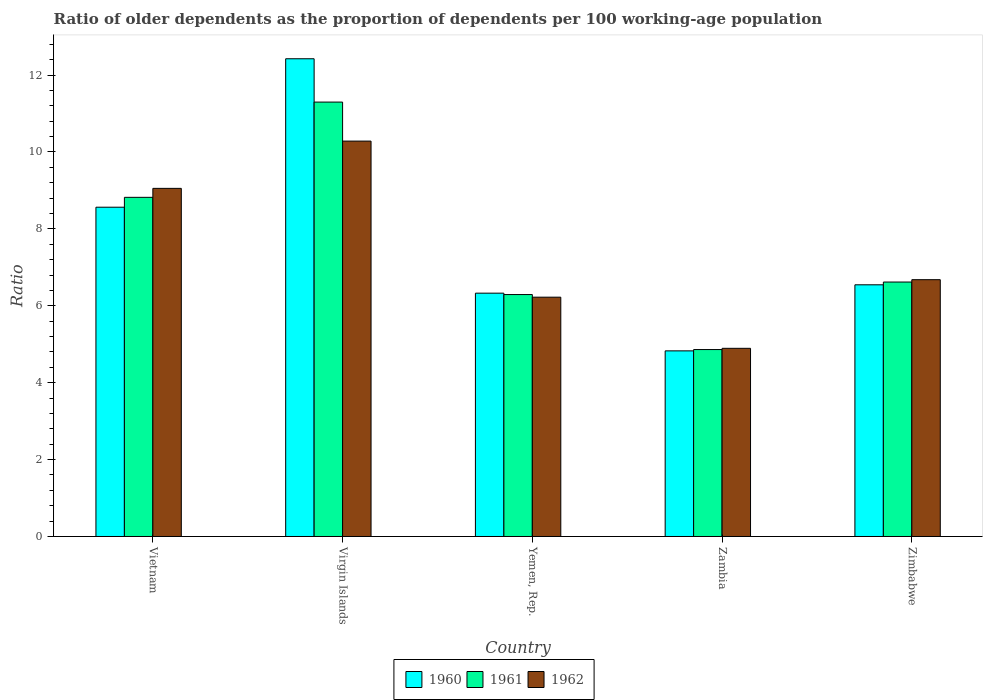How many different coloured bars are there?
Your answer should be very brief. 3. How many groups of bars are there?
Keep it short and to the point. 5. Are the number of bars per tick equal to the number of legend labels?
Provide a short and direct response. Yes. Are the number of bars on each tick of the X-axis equal?
Your answer should be compact. Yes. How many bars are there on the 3rd tick from the left?
Give a very brief answer. 3. How many bars are there on the 5th tick from the right?
Keep it short and to the point. 3. What is the label of the 1st group of bars from the left?
Ensure brevity in your answer.  Vietnam. In how many cases, is the number of bars for a given country not equal to the number of legend labels?
Provide a short and direct response. 0. What is the age dependency ratio(old) in 1961 in Zambia?
Provide a short and direct response. 4.86. Across all countries, what is the maximum age dependency ratio(old) in 1960?
Keep it short and to the point. 12.42. Across all countries, what is the minimum age dependency ratio(old) in 1962?
Your answer should be compact. 4.89. In which country was the age dependency ratio(old) in 1962 maximum?
Offer a very short reply. Virgin Islands. In which country was the age dependency ratio(old) in 1960 minimum?
Your response must be concise. Zambia. What is the total age dependency ratio(old) in 1961 in the graph?
Offer a very short reply. 37.89. What is the difference between the age dependency ratio(old) in 1961 in Virgin Islands and that in Zimbabwe?
Your answer should be compact. 4.68. What is the difference between the age dependency ratio(old) in 1960 in Vietnam and the age dependency ratio(old) in 1962 in Zimbabwe?
Provide a short and direct response. 1.88. What is the average age dependency ratio(old) in 1961 per country?
Provide a succinct answer. 7.58. What is the difference between the age dependency ratio(old) of/in 1961 and age dependency ratio(old) of/in 1962 in Zambia?
Offer a very short reply. -0.03. What is the ratio of the age dependency ratio(old) in 1961 in Zambia to that in Zimbabwe?
Offer a terse response. 0.73. Is the age dependency ratio(old) in 1961 in Vietnam less than that in Yemen, Rep.?
Keep it short and to the point. No. Is the difference between the age dependency ratio(old) in 1961 in Vietnam and Zambia greater than the difference between the age dependency ratio(old) in 1962 in Vietnam and Zambia?
Make the answer very short. No. What is the difference between the highest and the second highest age dependency ratio(old) in 1962?
Offer a very short reply. -1.23. What is the difference between the highest and the lowest age dependency ratio(old) in 1961?
Ensure brevity in your answer.  6.44. Is the sum of the age dependency ratio(old) in 1960 in Yemen, Rep. and Zambia greater than the maximum age dependency ratio(old) in 1961 across all countries?
Ensure brevity in your answer.  No. What does the 2nd bar from the right in Yemen, Rep. represents?
Offer a terse response. 1961. Is it the case that in every country, the sum of the age dependency ratio(old) in 1961 and age dependency ratio(old) in 1962 is greater than the age dependency ratio(old) in 1960?
Your answer should be very brief. Yes. What is the difference between two consecutive major ticks on the Y-axis?
Your answer should be very brief. 2. Are the values on the major ticks of Y-axis written in scientific E-notation?
Provide a short and direct response. No. Does the graph contain grids?
Your response must be concise. No. Where does the legend appear in the graph?
Make the answer very short. Bottom center. How many legend labels are there?
Give a very brief answer. 3. What is the title of the graph?
Your response must be concise. Ratio of older dependents as the proportion of dependents per 100 working-age population. What is the label or title of the X-axis?
Make the answer very short. Country. What is the label or title of the Y-axis?
Keep it short and to the point. Ratio. What is the Ratio in 1960 in Vietnam?
Your answer should be compact. 8.56. What is the Ratio of 1961 in Vietnam?
Your response must be concise. 8.82. What is the Ratio of 1962 in Vietnam?
Ensure brevity in your answer.  9.05. What is the Ratio in 1960 in Virgin Islands?
Your answer should be compact. 12.42. What is the Ratio in 1961 in Virgin Islands?
Provide a short and direct response. 11.3. What is the Ratio in 1962 in Virgin Islands?
Keep it short and to the point. 10.28. What is the Ratio in 1960 in Yemen, Rep.?
Your answer should be very brief. 6.33. What is the Ratio of 1961 in Yemen, Rep.?
Ensure brevity in your answer.  6.29. What is the Ratio of 1962 in Yemen, Rep.?
Ensure brevity in your answer.  6.22. What is the Ratio of 1960 in Zambia?
Your answer should be compact. 4.83. What is the Ratio of 1961 in Zambia?
Keep it short and to the point. 4.86. What is the Ratio of 1962 in Zambia?
Provide a succinct answer. 4.89. What is the Ratio in 1960 in Zimbabwe?
Provide a succinct answer. 6.55. What is the Ratio in 1961 in Zimbabwe?
Your answer should be very brief. 6.62. What is the Ratio of 1962 in Zimbabwe?
Your answer should be compact. 6.68. Across all countries, what is the maximum Ratio in 1960?
Provide a short and direct response. 12.42. Across all countries, what is the maximum Ratio in 1961?
Provide a short and direct response. 11.3. Across all countries, what is the maximum Ratio in 1962?
Give a very brief answer. 10.28. Across all countries, what is the minimum Ratio in 1960?
Give a very brief answer. 4.83. Across all countries, what is the minimum Ratio of 1961?
Offer a terse response. 4.86. Across all countries, what is the minimum Ratio in 1962?
Your response must be concise. 4.89. What is the total Ratio in 1960 in the graph?
Make the answer very short. 38.69. What is the total Ratio in 1961 in the graph?
Your answer should be compact. 37.89. What is the total Ratio of 1962 in the graph?
Make the answer very short. 37.13. What is the difference between the Ratio of 1960 in Vietnam and that in Virgin Islands?
Your answer should be very brief. -3.86. What is the difference between the Ratio in 1961 in Vietnam and that in Virgin Islands?
Make the answer very short. -2.48. What is the difference between the Ratio of 1962 in Vietnam and that in Virgin Islands?
Offer a terse response. -1.23. What is the difference between the Ratio in 1960 in Vietnam and that in Yemen, Rep.?
Make the answer very short. 2.24. What is the difference between the Ratio in 1961 in Vietnam and that in Yemen, Rep.?
Give a very brief answer. 2.53. What is the difference between the Ratio in 1962 in Vietnam and that in Yemen, Rep.?
Keep it short and to the point. 2.83. What is the difference between the Ratio of 1960 in Vietnam and that in Zambia?
Your response must be concise. 3.74. What is the difference between the Ratio in 1961 in Vietnam and that in Zambia?
Offer a terse response. 3.96. What is the difference between the Ratio in 1962 in Vietnam and that in Zambia?
Your answer should be very brief. 4.16. What is the difference between the Ratio in 1960 in Vietnam and that in Zimbabwe?
Ensure brevity in your answer.  2.02. What is the difference between the Ratio of 1961 in Vietnam and that in Zimbabwe?
Your response must be concise. 2.2. What is the difference between the Ratio in 1962 in Vietnam and that in Zimbabwe?
Give a very brief answer. 2.37. What is the difference between the Ratio of 1960 in Virgin Islands and that in Yemen, Rep.?
Make the answer very short. 6.1. What is the difference between the Ratio of 1961 in Virgin Islands and that in Yemen, Rep.?
Offer a very short reply. 5.01. What is the difference between the Ratio in 1962 in Virgin Islands and that in Yemen, Rep.?
Your answer should be very brief. 4.06. What is the difference between the Ratio of 1960 in Virgin Islands and that in Zambia?
Your response must be concise. 7.6. What is the difference between the Ratio of 1961 in Virgin Islands and that in Zambia?
Your answer should be very brief. 6.44. What is the difference between the Ratio in 1962 in Virgin Islands and that in Zambia?
Provide a short and direct response. 5.39. What is the difference between the Ratio in 1960 in Virgin Islands and that in Zimbabwe?
Your answer should be compact. 5.88. What is the difference between the Ratio of 1961 in Virgin Islands and that in Zimbabwe?
Offer a very short reply. 4.68. What is the difference between the Ratio of 1962 in Virgin Islands and that in Zimbabwe?
Your answer should be very brief. 3.6. What is the difference between the Ratio of 1960 in Yemen, Rep. and that in Zambia?
Give a very brief answer. 1.5. What is the difference between the Ratio in 1961 in Yemen, Rep. and that in Zambia?
Your answer should be very brief. 1.43. What is the difference between the Ratio in 1962 in Yemen, Rep. and that in Zambia?
Offer a terse response. 1.33. What is the difference between the Ratio of 1960 in Yemen, Rep. and that in Zimbabwe?
Give a very brief answer. -0.22. What is the difference between the Ratio of 1961 in Yemen, Rep. and that in Zimbabwe?
Offer a very short reply. -0.33. What is the difference between the Ratio of 1962 in Yemen, Rep. and that in Zimbabwe?
Your answer should be very brief. -0.46. What is the difference between the Ratio of 1960 in Zambia and that in Zimbabwe?
Keep it short and to the point. -1.72. What is the difference between the Ratio in 1961 in Zambia and that in Zimbabwe?
Offer a terse response. -1.76. What is the difference between the Ratio in 1962 in Zambia and that in Zimbabwe?
Offer a terse response. -1.79. What is the difference between the Ratio of 1960 in Vietnam and the Ratio of 1961 in Virgin Islands?
Your answer should be very brief. -2.73. What is the difference between the Ratio of 1960 in Vietnam and the Ratio of 1962 in Virgin Islands?
Your answer should be very brief. -1.72. What is the difference between the Ratio of 1961 in Vietnam and the Ratio of 1962 in Virgin Islands?
Keep it short and to the point. -1.46. What is the difference between the Ratio of 1960 in Vietnam and the Ratio of 1961 in Yemen, Rep.?
Make the answer very short. 2.27. What is the difference between the Ratio of 1960 in Vietnam and the Ratio of 1962 in Yemen, Rep.?
Make the answer very short. 2.34. What is the difference between the Ratio of 1961 in Vietnam and the Ratio of 1962 in Yemen, Rep.?
Keep it short and to the point. 2.6. What is the difference between the Ratio in 1960 in Vietnam and the Ratio in 1961 in Zambia?
Your response must be concise. 3.7. What is the difference between the Ratio of 1960 in Vietnam and the Ratio of 1962 in Zambia?
Ensure brevity in your answer.  3.67. What is the difference between the Ratio in 1961 in Vietnam and the Ratio in 1962 in Zambia?
Your answer should be compact. 3.93. What is the difference between the Ratio of 1960 in Vietnam and the Ratio of 1961 in Zimbabwe?
Provide a succinct answer. 1.95. What is the difference between the Ratio in 1960 in Vietnam and the Ratio in 1962 in Zimbabwe?
Your response must be concise. 1.88. What is the difference between the Ratio of 1961 in Vietnam and the Ratio of 1962 in Zimbabwe?
Keep it short and to the point. 2.14. What is the difference between the Ratio of 1960 in Virgin Islands and the Ratio of 1961 in Yemen, Rep.?
Your answer should be very brief. 6.13. What is the difference between the Ratio in 1960 in Virgin Islands and the Ratio in 1962 in Yemen, Rep.?
Your answer should be very brief. 6.2. What is the difference between the Ratio in 1961 in Virgin Islands and the Ratio in 1962 in Yemen, Rep.?
Make the answer very short. 5.07. What is the difference between the Ratio in 1960 in Virgin Islands and the Ratio in 1961 in Zambia?
Provide a short and direct response. 7.56. What is the difference between the Ratio of 1960 in Virgin Islands and the Ratio of 1962 in Zambia?
Ensure brevity in your answer.  7.53. What is the difference between the Ratio of 1961 in Virgin Islands and the Ratio of 1962 in Zambia?
Give a very brief answer. 6.4. What is the difference between the Ratio of 1960 in Virgin Islands and the Ratio of 1961 in Zimbabwe?
Your answer should be compact. 5.81. What is the difference between the Ratio of 1960 in Virgin Islands and the Ratio of 1962 in Zimbabwe?
Your answer should be very brief. 5.75. What is the difference between the Ratio of 1961 in Virgin Islands and the Ratio of 1962 in Zimbabwe?
Provide a succinct answer. 4.62. What is the difference between the Ratio of 1960 in Yemen, Rep. and the Ratio of 1961 in Zambia?
Offer a very short reply. 1.47. What is the difference between the Ratio in 1960 in Yemen, Rep. and the Ratio in 1962 in Zambia?
Your answer should be very brief. 1.43. What is the difference between the Ratio of 1961 in Yemen, Rep. and the Ratio of 1962 in Zambia?
Keep it short and to the point. 1.4. What is the difference between the Ratio of 1960 in Yemen, Rep. and the Ratio of 1961 in Zimbabwe?
Provide a succinct answer. -0.29. What is the difference between the Ratio of 1960 in Yemen, Rep. and the Ratio of 1962 in Zimbabwe?
Keep it short and to the point. -0.35. What is the difference between the Ratio in 1961 in Yemen, Rep. and the Ratio in 1962 in Zimbabwe?
Offer a terse response. -0.39. What is the difference between the Ratio of 1960 in Zambia and the Ratio of 1961 in Zimbabwe?
Provide a succinct answer. -1.79. What is the difference between the Ratio in 1960 in Zambia and the Ratio in 1962 in Zimbabwe?
Provide a short and direct response. -1.85. What is the difference between the Ratio of 1961 in Zambia and the Ratio of 1962 in Zimbabwe?
Offer a very short reply. -1.82. What is the average Ratio of 1960 per country?
Offer a very short reply. 7.74. What is the average Ratio in 1961 per country?
Your answer should be very brief. 7.58. What is the average Ratio in 1962 per country?
Ensure brevity in your answer.  7.43. What is the difference between the Ratio of 1960 and Ratio of 1961 in Vietnam?
Keep it short and to the point. -0.26. What is the difference between the Ratio in 1960 and Ratio in 1962 in Vietnam?
Your answer should be very brief. -0.49. What is the difference between the Ratio of 1961 and Ratio of 1962 in Vietnam?
Ensure brevity in your answer.  -0.23. What is the difference between the Ratio in 1960 and Ratio in 1961 in Virgin Islands?
Ensure brevity in your answer.  1.13. What is the difference between the Ratio in 1960 and Ratio in 1962 in Virgin Islands?
Your answer should be compact. 2.14. What is the difference between the Ratio of 1961 and Ratio of 1962 in Virgin Islands?
Your answer should be compact. 1.01. What is the difference between the Ratio in 1960 and Ratio in 1961 in Yemen, Rep.?
Make the answer very short. 0.04. What is the difference between the Ratio in 1960 and Ratio in 1962 in Yemen, Rep.?
Offer a terse response. 0.1. What is the difference between the Ratio of 1961 and Ratio of 1962 in Yemen, Rep.?
Offer a very short reply. 0.07. What is the difference between the Ratio in 1960 and Ratio in 1961 in Zambia?
Provide a short and direct response. -0.03. What is the difference between the Ratio in 1960 and Ratio in 1962 in Zambia?
Provide a succinct answer. -0.07. What is the difference between the Ratio in 1961 and Ratio in 1962 in Zambia?
Your answer should be very brief. -0.03. What is the difference between the Ratio in 1960 and Ratio in 1961 in Zimbabwe?
Your response must be concise. -0.07. What is the difference between the Ratio of 1960 and Ratio of 1962 in Zimbabwe?
Give a very brief answer. -0.13. What is the difference between the Ratio of 1961 and Ratio of 1962 in Zimbabwe?
Offer a terse response. -0.06. What is the ratio of the Ratio in 1960 in Vietnam to that in Virgin Islands?
Your answer should be compact. 0.69. What is the ratio of the Ratio of 1961 in Vietnam to that in Virgin Islands?
Your response must be concise. 0.78. What is the ratio of the Ratio in 1962 in Vietnam to that in Virgin Islands?
Your response must be concise. 0.88. What is the ratio of the Ratio of 1960 in Vietnam to that in Yemen, Rep.?
Offer a very short reply. 1.35. What is the ratio of the Ratio in 1961 in Vietnam to that in Yemen, Rep.?
Your answer should be very brief. 1.4. What is the ratio of the Ratio of 1962 in Vietnam to that in Yemen, Rep.?
Your answer should be compact. 1.45. What is the ratio of the Ratio in 1960 in Vietnam to that in Zambia?
Your answer should be compact. 1.77. What is the ratio of the Ratio in 1961 in Vietnam to that in Zambia?
Ensure brevity in your answer.  1.81. What is the ratio of the Ratio of 1962 in Vietnam to that in Zambia?
Offer a terse response. 1.85. What is the ratio of the Ratio in 1960 in Vietnam to that in Zimbabwe?
Keep it short and to the point. 1.31. What is the ratio of the Ratio of 1961 in Vietnam to that in Zimbabwe?
Provide a short and direct response. 1.33. What is the ratio of the Ratio of 1962 in Vietnam to that in Zimbabwe?
Ensure brevity in your answer.  1.36. What is the ratio of the Ratio in 1960 in Virgin Islands to that in Yemen, Rep.?
Provide a succinct answer. 1.96. What is the ratio of the Ratio of 1961 in Virgin Islands to that in Yemen, Rep.?
Ensure brevity in your answer.  1.8. What is the ratio of the Ratio in 1962 in Virgin Islands to that in Yemen, Rep.?
Provide a short and direct response. 1.65. What is the ratio of the Ratio of 1960 in Virgin Islands to that in Zambia?
Offer a terse response. 2.57. What is the ratio of the Ratio of 1961 in Virgin Islands to that in Zambia?
Keep it short and to the point. 2.32. What is the ratio of the Ratio of 1962 in Virgin Islands to that in Zambia?
Make the answer very short. 2.1. What is the ratio of the Ratio in 1960 in Virgin Islands to that in Zimbabwe?
Provide a succinct answer. 1.9. What is the ratio of the Ratio of 1961 in Virgin Islands to that in Zimbabwe?
Offer a terse response. 1.71. What is the ratio of the Ratio in 1962 in Virgin Islands to that in Zimbabwe?
Your response must be concise. 1.54. What is the ratio of the Ratio of 1960 in Yemen, Rep. to that in Zambia?
Your answer should be compact. 1.31. What is the ratio of the Ratio in 1961 in Yemen, Rep. to that in Zambia?
Provide a succinct answer. 1.29. What is the ratio of the Ratio of 1962 in Yemen, Rep. to that in Zambia?
Your answer should be compact. 1.27. What is the ratio of the Ratio of 1960 in Yemen, Rep. to that in Zimbabwe?
Your response must be concise. 0.97. What is the ratio of the Ratio in 1961 in Yemen, Rep. to that in Zimbabwe?
Provide a short and direct response. 0.95. What is the ratio of the Ratio of 1962 in Yemen, Rep. to that in Zimbabwe?
Keep it short and to the point. 0.93. What is the ratio of the Ratio in 1960 in Zambia to that in Zimbabwe?
Keep it short and to the point. 0.74. What is the ratio of the Ratio in 1961 in Zambia to that in Zimbabwe?
Make the answer very short. 0.73. What is the ratio of the Ratio in 1962 in Zambia to that in Zimbabwe?
Make the answer very short. 0.73. What is the difference between the highest and the second highest Ratio in 1960?
Offer a terse response. 3.86. What is the difference between the highest and the second highest Ratio of 1961?
Keep it short and to the point. 2.48. What is the difference between the highest and the second highest Ratio in 1962?
Make the answer very short. 1.23. What is the difference between the highest and the lowest Ratio of 1960?
Provide a short and direct response. 7.6. What is the difference between the highest and the lowest Ratio in 1961?
Offer a terse response. 6.44. What is the difference between the highest and the lowest Ratio of 1962?
Make the answer very short. 5.39. 